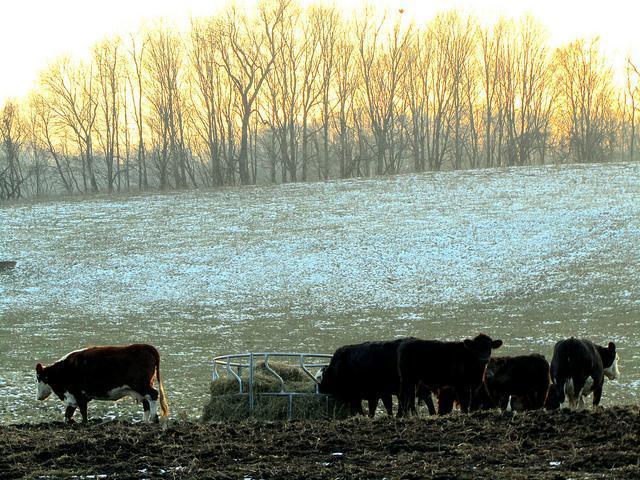How many cows can be seen?
Give a very brief answer. 5. How many chairs or sofas have a red pillow?
Give a very brief answer. 0. 